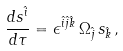Convert formula to latex. <formula><loc_0><loc_0><loc_500><loc_500>\frac { d s ^ { \hat { i } } } { d \tau } = \epsilon ^ { \hat { i } \hat { j } \hat { k } } \, \Omega _ { \hat { j } } \, s _ { \hat { k } } \, ,</formula> 